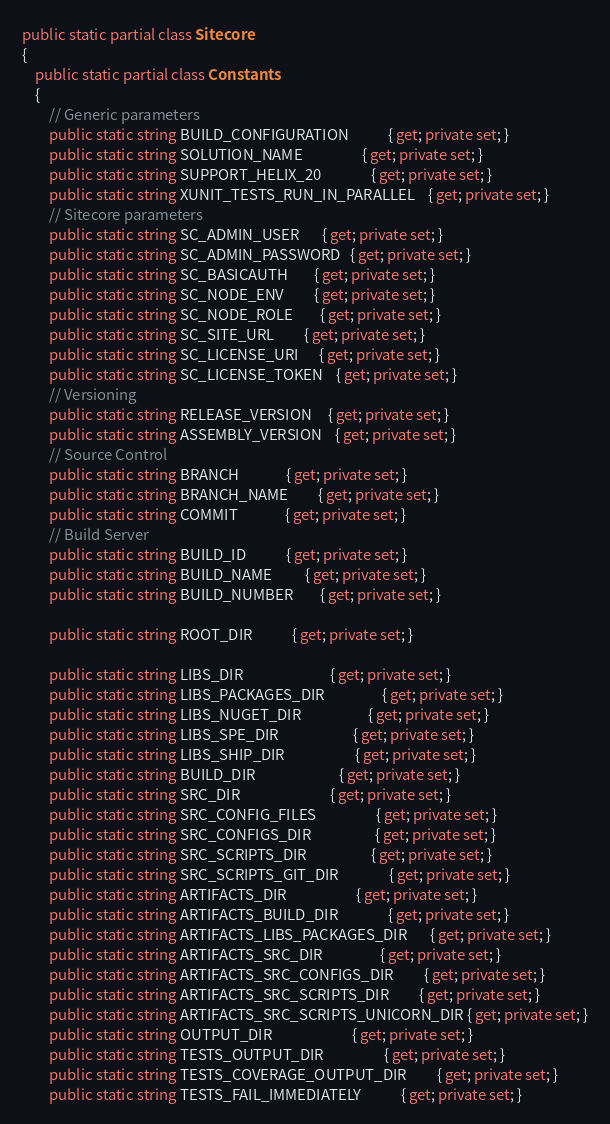<code> <loc_0><loc_0><loc_500><loc_500><_C#_>public static partial class Sitecore
{
    public static partial class Constants
    {
        // Generic parameters
        public static string BUILD_CONFIGURATION            { get; private set; }
        public static string SOLUTION_NAME                  { get; private set; }
        public static string SUPPORT_HELIX_20               { get; private set; }
        public static string XUNIT_TESTS_RUN_IN_PARALLEL    { get; private set; }
        // Sitecore parameters
        public static string SC_ADMIN_USER       { get; private set; }
        public static string SC_ADMIN_PASSWORD   { get; private set; }
        public static string SC_BASICAUTH        { get; private set; }
        public static string SC_NODE_ENV         { get; private set; }
        public static string SC_NODE_ROLE        { get; private set; }
        public static string SC_SITE_URL         { get; private set; }
        public static string SC_LICENSE_URI      { get; private set; }
        public static string SC_LICENSE_TOKEN    { get; private set; }
        // Versioning
        public static string RELEASE_VERSION     { get; private set; }
        public static string ASSEMBLY_VERSION    { get; private set; }
        // Source Control
        public static string BRANCH              { get; private set; }
        public static string BRANCH_NAME         { get; private set; }
        public static string COMMIT              { get; private set; }
        // Build Server
        public static string BUILD_ID            { get; private set; }
        public static string BUILD_NAME          { get; private set; }
        public static string BUILD_NUMBER        { get; private set; }

        public static string ROOT_DIR            { get; private set; }

        public static string LIBS_DIR                          { get; private set; }
        public static string LIBS_PACKAGES_DIR                 { get; private set; }
        public static string LIBS_NUGET_DIR                    { get; private set; }
        public static string LIBS_SPE_DIR                      { get; private set; }
        public static string LIBS_SHIP_DIR                     { get; private set; }
        public static string BUILD_DIR                         { get; private set; }
        public static string SRC_DIR                           { get; private set; }
        public static string SRC_CONFIG_FILES                  { get; private set; }
        public static string SRC_CONFIGS_DIR                   { get; private set; }
        public static string SRC_SCRIPTS_DIR                   { get; private set; }
        public static string SRC_SCRIPTS_GIT_DIR               { get; private set; }
        public static string ARTIFACTS_DIR                     { get; private set; }
        public static string ARTIFACTS_BUILD_DIR               { get; private set; }
        public static string ARTIFACTS_LIBS_PACKAGES_DIR       { get; private set; }
        public static string ARTIFACTS_SRC_DIR                 { get; private set; }
        public static string ARTIFACTS_SRC_CONFIGS_DIR         { get; private set; }
        public static string ARTIFACTS_SRC_SCRIPTS_DIR         { get; private set; }
        public static string ARTIFACTS_SRC_SCRIPTS_UNICORN_DIR { get; private set; }
        public static string OUTPUT_DIR                        { get; private set; }
        public static string TESTS_OUTPUT_DIR                  { get; private set; }
        public static string TESTS_COVERAGE_OUTPUT_DIR         { get; private set; }
        public static string TESTS_FAIL_IMMEDIATELY            { get; private set; }</code> 